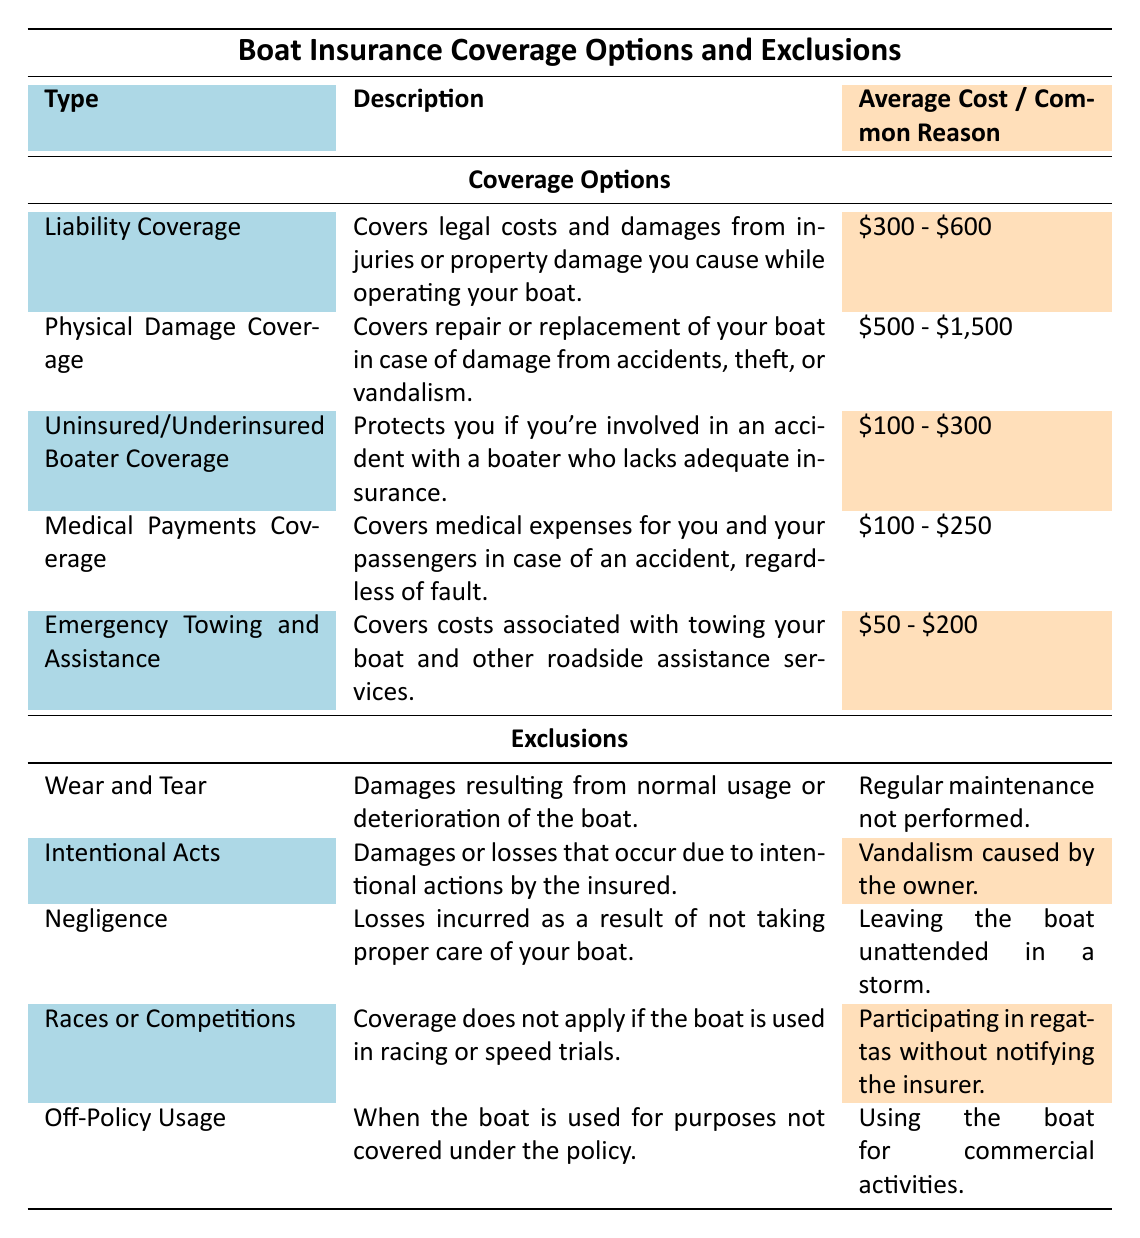What's the average cost range for Liability Coverage? The table states that the average cost for Liability Coverage is between $300 and $600. Therefore, the average cost range can be identified directly from this description.
Answer: $300 - $600 What is covered under Physical Damage Coverage? According to the table, Physical Damage Coverage covers the repair or replacement of your boat in case of damage from accidents, theft, or vandalism. This information is explicitly mentioned in the coverage description.
Answer: Repair or replacement of the boat due to accidents, theft, or vandalism Is Uninsured/Underinsured Boater Coverage less expensive than Medical Payments Coverage? The average cost for Uninsured/Underinsured Boater Coverage ranges from $100 to $300, while the average cost for Medical Payments Coverage ranges from $100 to $250. Since the upper limit of Medical Payments Coverage is $250, it is indeed less expensive than Uninsured/Underinsured Boater Coverage, which goes up to $300.
Answer: Yes What type of damages does Wear and Tear exclude from coverage? The table states that Wear and Tear excludes damages resulting from normal usage or deterioration of the boat. This provides clear guidelines on the types of damages that are not covered under the insurance policy.
Answer: Damages from normal usage or deterioration If I want to ensure coverage for my boat during a race, which option should I choose? The table clearly indicates that damages related to racing or speed trials are excluded under the "Races or Competitions" section. Therefore, no coverage under the current policy options can cover damages from a race, and you would need a specific policy for such activities.
Answer: None of the options provide coverage for races; a specific policy is needed What is the common reason for the exclusion of Off-Policy Usage? The reason given in the table for the exclusion of Off-Policy Usage is using the boat for commercial activities. This specific example helps clarify when the coverage will not apply.
Answer: Using the boat for commercial activities What is the total average cost range if I select both Emergency Towing and Assistance and Medical Payments Coverage? The average cost for Emergency Towing and Assistance ranges from $50 to $200, and for Medical Payments Coverage, it ranges from $100 to $250. To find the total possible range, we add the lowest costs and the highest costs: $50 + $100 = $150 (minimum) and $200 + $250 = $450 (maximum). Hence, the total average cost range is from $150 to $450.
Answer: $150 - $450 Does the table provide a coverage option for damages due to owner vandalism? Yes, the table specifies that damages or losses due to vandalism caused by the owner fall under the exclusion of "Intentional Acts," which indicates that such damages are not covered by the policy.
Answer: Yes 